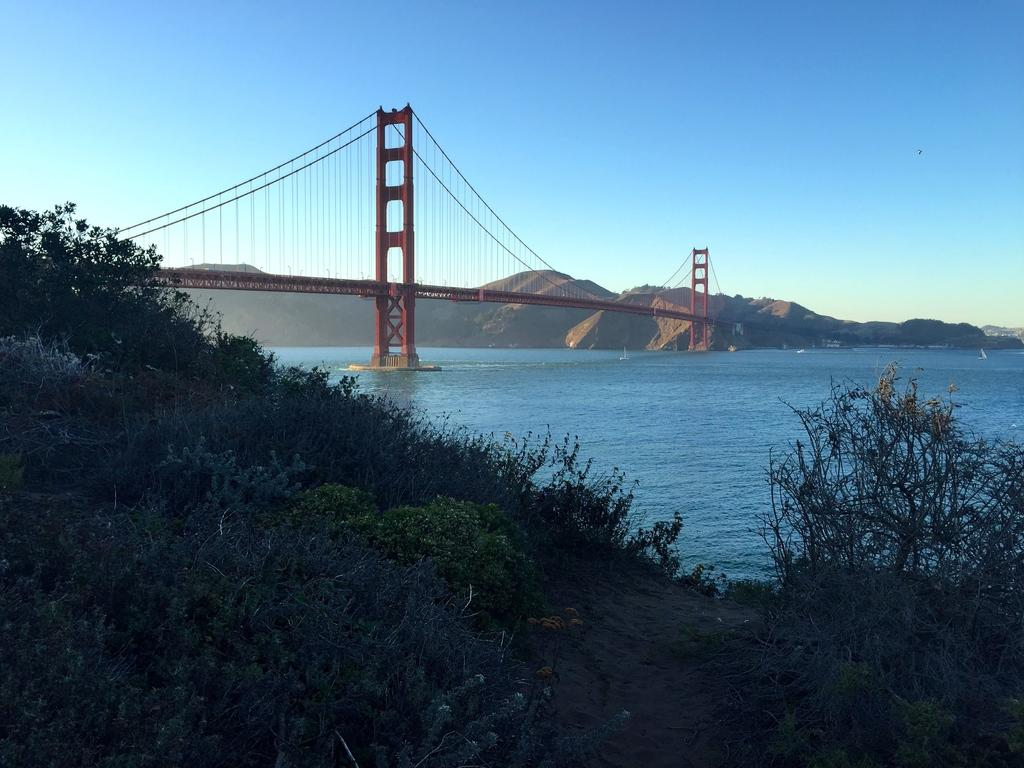What type of natural elements can be seen in the front of the image? There are plants and trees in the front of the image. What is located in the center of the image? There is water in the center of the image. What structure is present in the image? There is a bridge in the image. What type of geographical feature can be seen in the background of the image? There are mountains in the image. Who is the owner of the pin in the image? There is no pin present in the image, so it is not possible to determine the owner. 